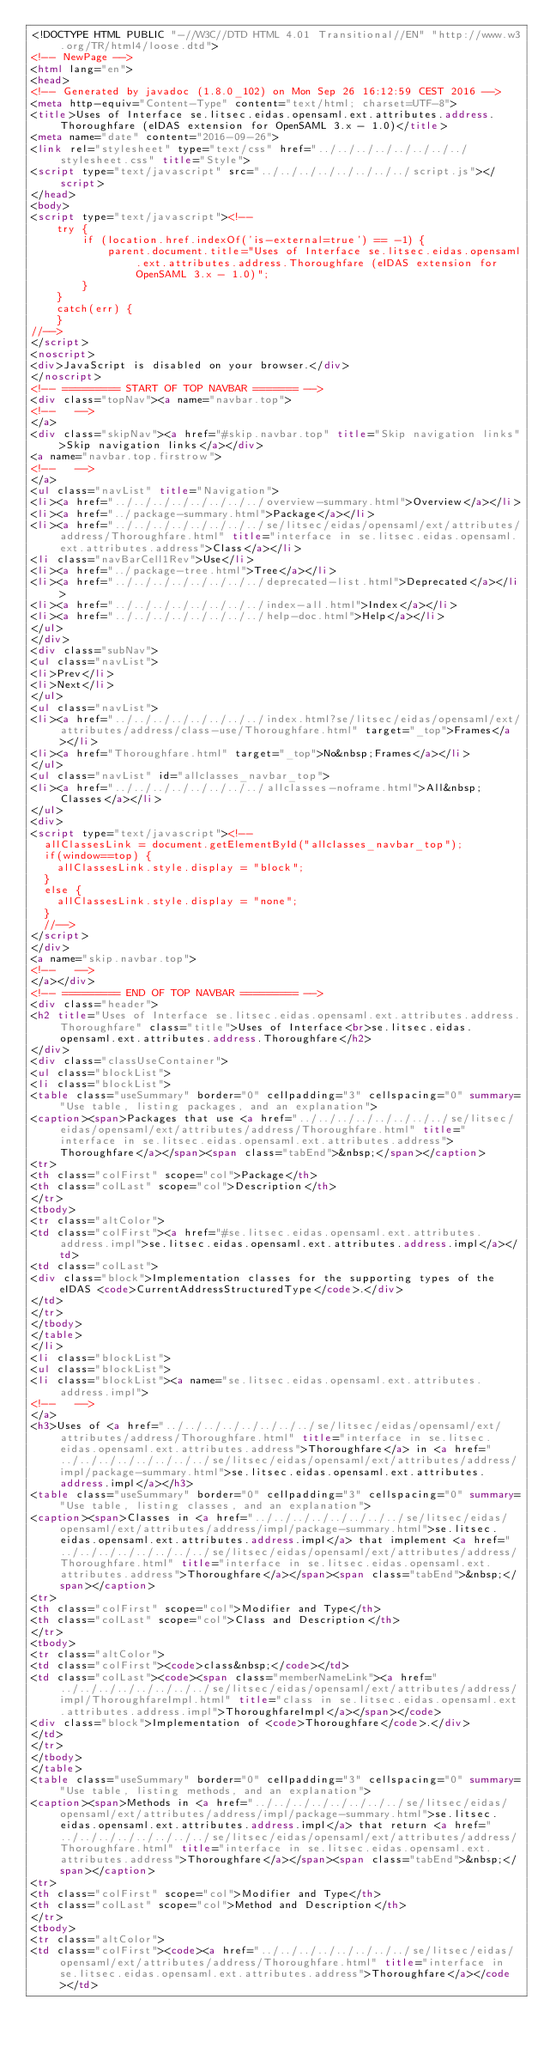Convert code to text. <code><loc_0><loc_0><loc_500><loc_500><_HTML_><!DOCTYPE HTML PUBLIC "-//W3C//DTD HTML 4.01 Transitional//EN" "http://www.w3.org/TR/html4/loose.dtd">
<!-- NewPage -->
<html lang="en">
<head>
<!-- Generated by javadoc (1.8.0_102) on Mon Sep 26 16:12:59 CEST 2016 -->
<meta http-equiv="Content-Type" content="text/html; charset=UTF-8">
<title>Uses of Interface se.litsec.eidas.opensaml.ext.attributes.address.Thoroughfare (eIDAS extension for OpenSAML 3.x - 1.0)</title>
<meta name="date" content="2016-09-26">
<link rel="stylesheet" type="text/css" href="../../../../../../../../stylesheet.css" title="Style">
<script type="text/javascript" src="../../../../../../../../script.js"></script>
</head>
<body>
<script type="text/javascript"><!--
    try {
        if (location.href.indexOf('is-external=true') == -1) {
            parent.document.title="Uses of Interface se.litsec.eidas.opensaml.ext.attributes.address.Thoroughfare (eIDAS extension for OpenSAML 3.x - 1.0)";
        }
    }
    catch(err) {
    }
//-->
</script>
<noscript>
<div>JavaScript is disabled on your browser.</div>
</noscript>
<!-- ========= START OF TOP NAVBAR ======= -->
<div class="topNav"><a name="navbar.top">
<!--   -->
</a>
<div class="skipNav"><a href="#skip.navbar.top" title="Skip navigation links">Skip navigation links</a></div>
<a name="navbar.top.firstrow">
<!--   -->
</a>
<ul class="navList" title="Navigation">
<li><a href="../../../../../../../../overview-summary.html">Overview</a></li>
<li><a href="../package-summary.html">Package</a></li>
<li><a href="../../../../../../../../se/litsec/eidas/opensaml/ext/attributes/address/Thoroughfare.html" title="interface in se.litsec.eidas.opensaml.ext.attributes.address">Class</a></li>
<li class="navBarCell1Rev">Use</li>
<li><a href="../package-tree.html">Tree</a></li>
<li><a href="../../../../../../../../deprecated-list.html">Deprecated</a></li>
<li><a href="../../../../../../../../index-all.html">Index</a></li>
<li><a href="../../../../../../../../help-doc.html">Help</a></li>
</ul>
</div>
<div class="subNav">
<ul class="navList">
<li>Prev</li>
<li>Next</li>
</ul>
<ul class="navList">
<li><a href="../../../../../../../../index.html?se/litsec/eidas/opensaml/ext/attributes/address/class-use/Thoroughfare.html" target="_top">Frames</a></li>
<li><a href="Thoroughfare.html" target="_top">No&nbsp;Frames</a></li>
</ul>
<ul class="navList" id="allclasses_navbar_top">
<li><a href="../../../../../../../../allclasses-noframe.html">All&nbsp;Classes</a></li>
</ul>
<div>
<script type="text/javascript"><!--
  allClassesLink = document.getElementById("allclasses_navbar_top");
  if(window==top) {
    allClassesLink.style.display = "block";
  }
  else {
    allClassesLink.style.display = "none";
  }
  //-->
</script>
</div>
<a name="skip.navbar.top">
<!--   -->
</a></div>
<!-- ========= END OF TOP NAVBAR ========= -->
<div class="header">
<h2 title="Uses of Interface se.litsec.eidas.opensaml.ext.attributes.address.Thoroughfare" class="title">Uses of Interface<br>se.litsec.eidas.opensaml.ext.attributes.address.Thoroughfare</h2>
</div>
<div class="classUseContainer">
<ul class="blockList">
<li class="blockList">
<table class="useSummary" border="0" cellpadding="3" cellspacing="0" summary="Use table, listing packages, and an explanation">
<caption><span>Packages that use <a href="../../../../../../../../se/litsec/eidas/opensaml/ext/attributes/address/Thoroughfare.html" title="interface in se.litsec.eidas.opensaml.ext.attributes.address">Thoroughfare</a></span><span class="tabEnd">&nbsp;</span></caption>
<tr>
<th class="colFirst" scope="col">Package</th>
<th class="colLast" scope="col">Description</th>
</tr>
<tbody>
<tr class="altColor">
<td class="colFirst"><a href="#se.litsec.eidas.opensaml.ext.attributes.address.impl">se.litsec.eidas.opensaml.ext.attributes.address.impl</a></td>
<td class="colLast">
<div class="block">Implementation classes for the supporting types of the eIDAS <code>CurrentAddressStructuredType</code>.</div>
</td>
</tr>
</tbody>
</table>
</li>
<li class="blockList">
<ul class="blockList">
<li class="blockList"><a name="se.litsec.eidas.opensaml.ext.attributes.address.impl">
<!--   -->
</a>
<h3>Uses of <a href="../../../../../../../../se/litsec/eidas/opensaml/ext/attributes/address/Thoroughfare.html" title="interface in se.litsec.eidas.opensaml.ext.attributes.address">Thoroughfare</a> in <a href="../../../../../../../../se/litsec/eidas/opensaml/ext/attributes/address/impl/package-summary.html">se.litsec.eidas.opensaml.ext.attributes.address.impl</a></h3>
<table class="useSummary" border="0" cellpadding="3" cellspacing="0" summary="Use table, listing classes, and an explanation">
<caption><span>Classes in <a href="../../../../../../../../se/litsec/eidas/opensaml/ext/attributes/address/impl/package-summary.html">se.litsec.eidas.opensaml.ext.attributes.address.impl</a> that implement <a href="../../../../../../../../se/litsec/eidas/opensaml/ext/attributes/address/Thoroughfare.html" title="interface in se.litsec.eidas.opensaml.ext.attributes.address">Thoroughfare</a></span><span class="tabEnd">&nbsp;</span></caption>
<tr>
<th class="colFirst" scope="col">Modifier and Type</th>
<th class="colLast" scope="col">Class and Description</th>
</tr>
<tbody>
<tr class="altColor">
<td class="colFirst"><code>class&nbsp;</code></td>
<td class="colLast"><code><span class="memberNameLink"><a href="../../../../../../../../se/litsec/eidas/opensaml/ext/attributes/address/impl/ThoroughfareImpl.html" title="class in se.litsec.eidas.opensaml.ext.attributes.address.impl">ThoroughfareImpl</a></span></code>
<div class="block">Implementation of <code>Thoroughfare</code>.</div>
</td>
</tr>
</tbody>
</table>
<table class="useSummary" border="0" cellpadding="3" cellspacing="0" summary="Use table, listing methods, and an explanation">
<caption><span>Methods in <a href="../../../../../../../../se/litsec/eidas/opensaml/ext/attributes/address/impl/package-summary.html">se.litsec.eidas.opensaml.ext.attributes.address.impl</a> that return <a href="../../../../../../../../se/litsec/eidas/opensaml/ext/attributes/address/Thoroughfare.html" title="interface in se.litsec.eidas.opensaml.ext.attributes.address">Thoroughfare</a></span><span class="tabEnd">&nbsp;</span></caption>
<tr>
<th class="colFirst" scope="col">Modifier and Type</th>
<th class="colLast" scope="col">Method and Description</th>
</tr>
<tbody>
<tr class="altColor">
<td class="colFirst"><code><a href="../../../../../../../../se/litsec/eidas/opensaml/ext/attributes/address/Thoroughfare.html" title="interface in se.litsec.eidas.opensaml.ext.attributes.address">Thoroughfare</a></code></td></code> 